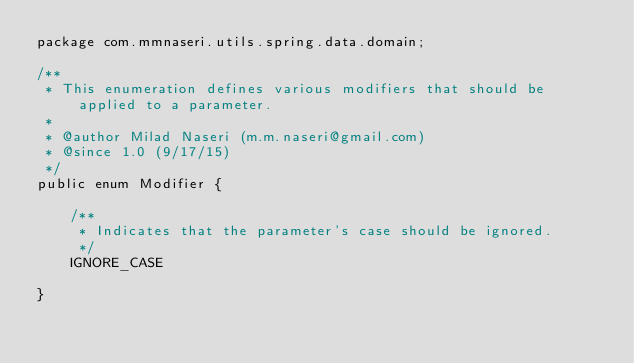<code> <loc_0><loc_0><loc_500><loc_500><_Java_>package com.mmnaseri.utils.spring.data.domain;

/**
 * This enumeration defines various modifiers that should be applied to a parameter.
 *
 * @author Milad Naseri (m.m.naseri@gmail.com)
 * @since 1.0 (9/17/15)
 */
public enum Modifier {

    /**
     * Indicates that the parameter's case should be ignored.
     */
    IGNORE_CASE

}
</code> 